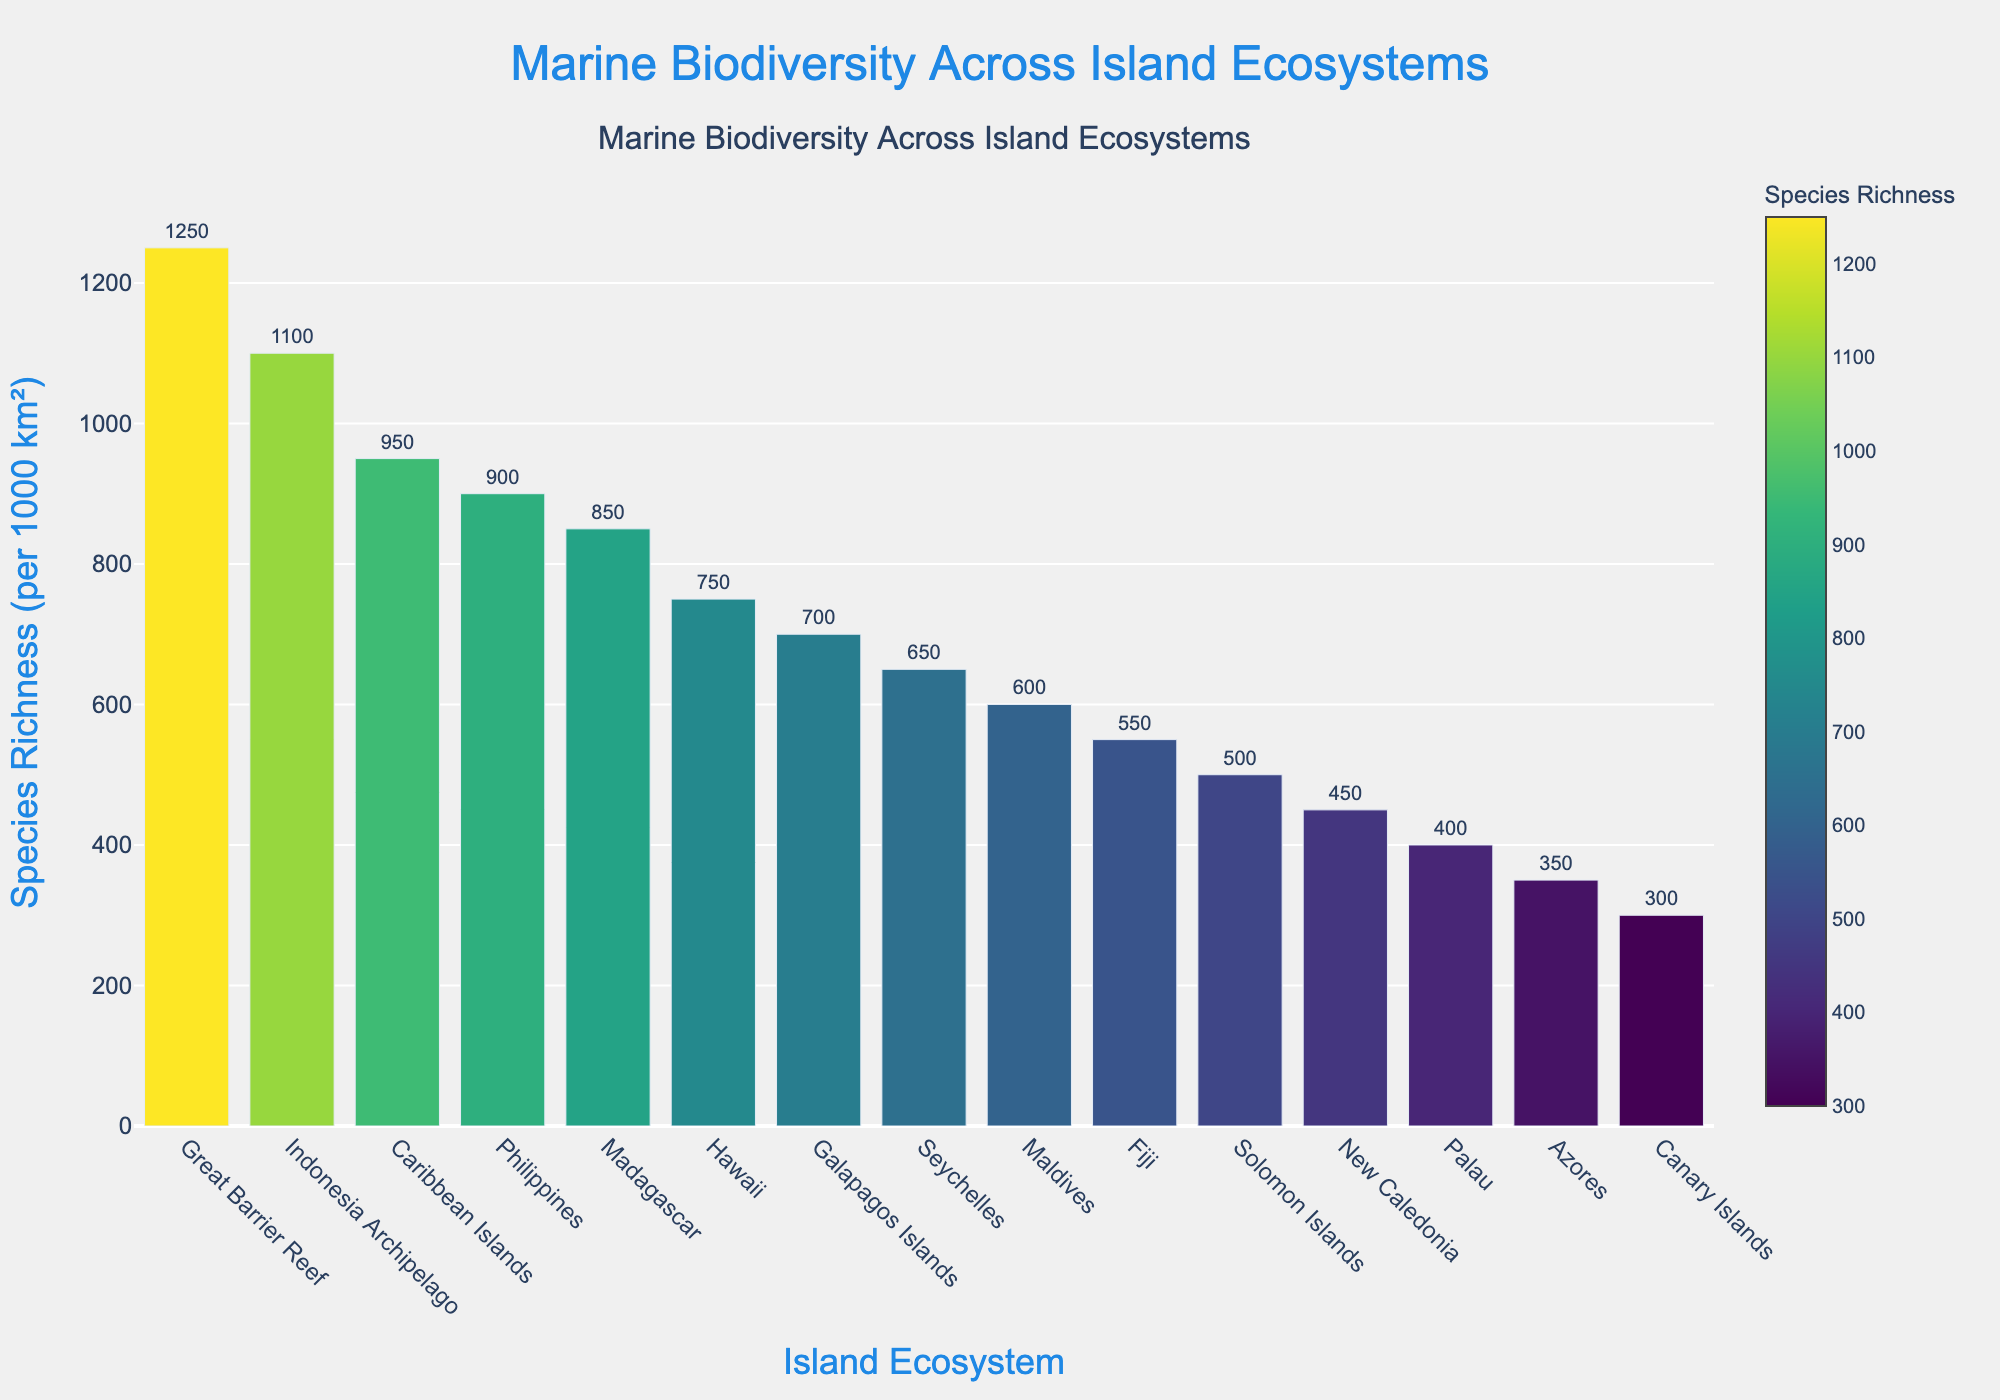Which island ecosystem has the highest species richness? By looking at the height of the bars, we can see that the Great Barrier Reef has the tallest bar in the chart, indicating it has the highest species richness.
Answer: Great Barrier Reef Which two island ecosystems have the closest species richness values? By examining the heights of the bars and comparing the numbers, Indonesia Archipelago has a species richness of 1100, and the Caribbean Islands have a species richness of 950. However, the Philippines, with a species richness of 900, is closest to the Caribbean Islands.
Answer: Philippines and Caribbean Islands What is the species richness difference between the Seychelles and the Solomon Islands? From the figure, the Seychelles have a species richness of 650, and the Solomon Islands have a species richness of 500. Subtracting these values gives 650 - 500.
Answer: 150 Which island ecosystem ranks third in species richness? In descending order, the third bar from the top is for the Caribbean Islands, indicating they rank third in species richness.
Answer: Caribbean Islands What is the average species richness of the top five island ecosystems? The species richness values for the top five islands are 1250, 1100, 950, 900, and 850. Adding these gives 1250 + 1100 + 950 + 900 + 850 = 5050. Dividing by 5, the average is 5050/5.
Answer: 1010 Compare the species richness of Madagascar and Seychelles. Which one is higher? By looking at the height of their respective bars, we can see that Madagascar (850) has a higher bar than Seychelles (650), indicating higher species richness.
Answer: Madagascar Which ecosystem has a species richness of 600? By locating the bar with a height corresponding to 600, we see that the Maldives have a species richness of 600.
Answer: Maldives What is the difference in species richness between the highest and lowest ecosystems? The highest species richness is for the Great Barrier Reef (1250), and the lowest is for the Canary Islands (300). The difference is 1250 - 300.
Answer: 950 Which two island ecosystems exhibit the maximum difference in species richness? By comparing the extremes, the Great Barrier Reef (1250) and the Canary Islands (300) exhibit the maximum difference.
Answer: Great Barrier Reef and Canary Islands What is the total species richness for Indonesia Archipelago, Fiji, and New Caledonia combined? Summing the species richness values of 1100 (Indonesia Archipelago), 550 (Fiji), and 450 (New Caledonia), gives 1100 + 550 + 450.
Answer: 2100 